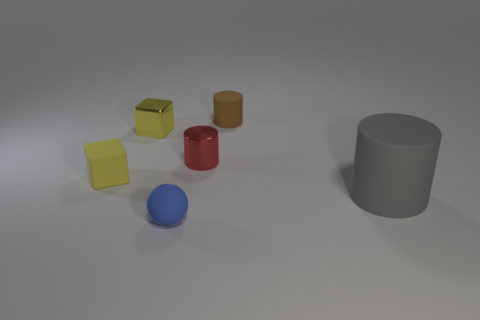The other large matte thing that is the same shape as the red object is what color?
Your answer should be very brief. Gray. How many tiny shiny cylinders are the same color as the tiny matte sphere?
Your answer should be compact. 0. Are there any other things that are the same shape as the gray matte object?
Keep it short and to the point. Yes. Is there a tiny red shiny thing left of the small shiny thing to the right of the rubber object that is in front of the large gray rubber thing?
Make the answer very short. No. What number of other blue balls have the same material as the small blue ball?
Your answer should be very brief. 0. There is a rubber cylinder in front of the brown thing; is its size the same as the thing in front of the gray rubber thing?
Your response must be concise. No. What color is the cylinder on the left side of the tiny brown rubber cylinder that is on the right side of the tiny thing that is left of the metallic cube?
Keep it short and to the point. Red. Is there another small brown thing that has the same shape as the small brown thing?
Make the answer very short. No. Are there the same number of blue matte objects that are behind the tiny yellow matte thing and tiny brown rubber things that are in front of the small brown cylinder?
Keep it short and to the point. Yes. There is a small metal object to the right of the tiny blue object; is it the same shape as the yellow matte thing?
Provide a short and direct response. No. 